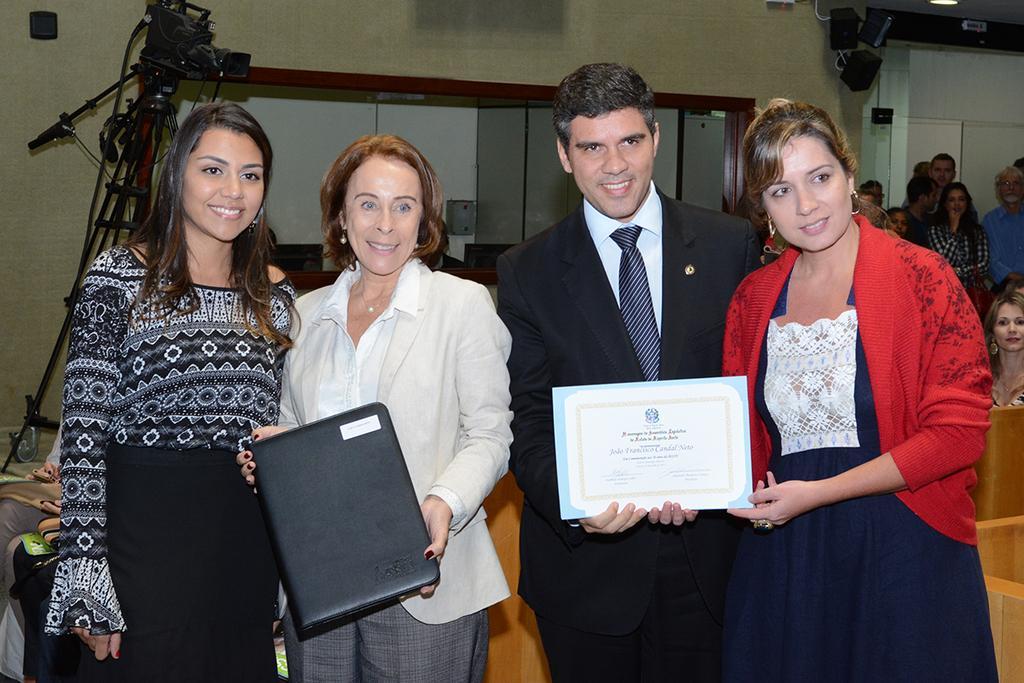Could you give a brief overview of what you see in this image? In this image there are two women one of them were holding a file, beside her there is a men and women they both are holding a certificate, in the background there is a camera and wall to that there is glass shelf, in the right side corner there are few persons. 